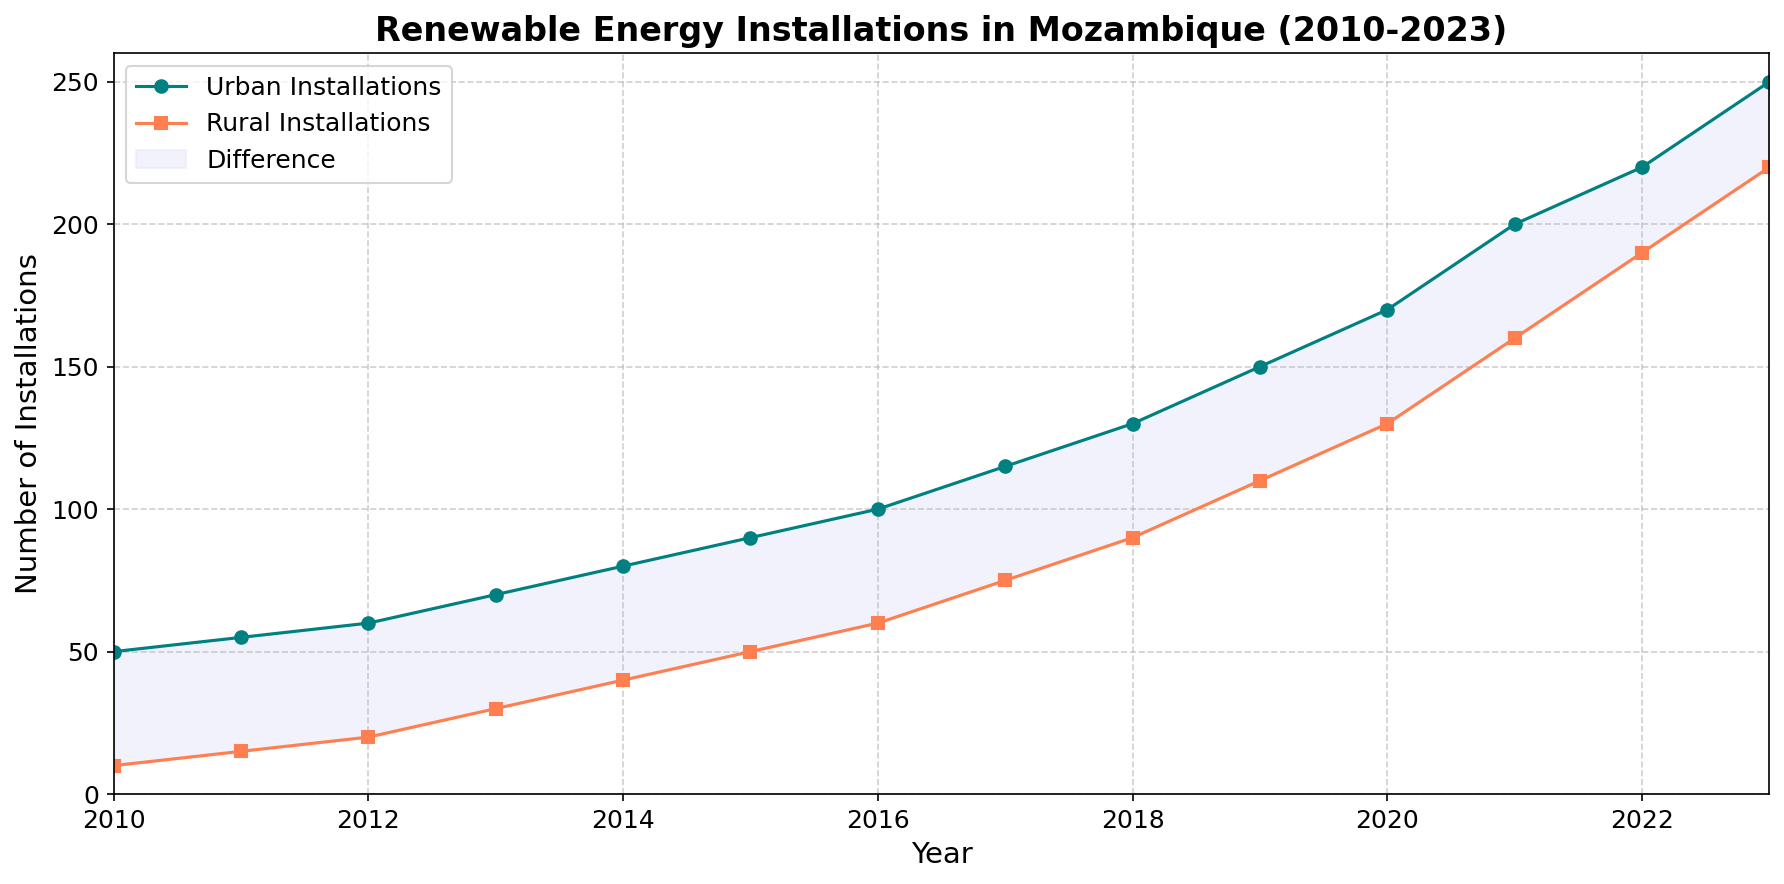What's the total number of urban installations in 2015? Refer to the plot and locate the year 2015 on the x-axis. The y-value for urban installations in 2015 is 90.
Answer: 90 What is the difference in the number of installations between urban and rural areas in 2018? In 2018, urban installations are at 130 and rural installations are at 90. Subtract rural from urban: 130 - 90 = 40.
Answer: 40 Which year experienced the greatest increase in urban installations? Check the largest jump in the slope for the urban line. The steepest increase occurs between 2021 and 2022, where installations go from 200 to 220, a difference of 20.
Answer: 2021-2022 How do rural installations in 2020 compare to urban installations in 2016? Locate rural installations for 2020 (130) and compare with urban installations for 2016 (100). 130 is greater than 100.
Answer: Rural 2020 > Urban 2016 What is the average number of rural installations between 2010 and 2015 inclusive? Rural installations from 2010 to 2015 are 10, 15, 20, 30, 40, and 50. Sum these values: 10 + 15 + 20 + 30 + 40 + 50 = 165. There are 6 years, so divide by 6: 165 / 6 = 27.5.
Answer: 27.5 What color represents the area between urban and rural installations? Look at the color used in the filled area between the urban and rural lines. It is lavender.
Answer: lavender How many urban installations were there at the start and end of the period from 2010 to 2023? Urban installations in 2010 are 50 and in 2023 they are 250.
Answer: Start: 50; End: 250 Which type of installations saw a higher rate of increase between 2010 and 2023? Compare slopes of the urban and rural lines from 2010 to 2023. Urban installations rise from 50 to 250, which is an increase of 200. Rural installations rise from 10 to 220, which is an increase of 210. The rural rate of increase is higher.
Answer: Rural rate is higher If the trend continues, what would be the projected number of rural installations for 2024? Check the recent trend in rural installations between 2022 (190) and 2023 (220). The increase is 30. Adding this to the 2023 value: 220 + 30 = 250.
Answer: 250 